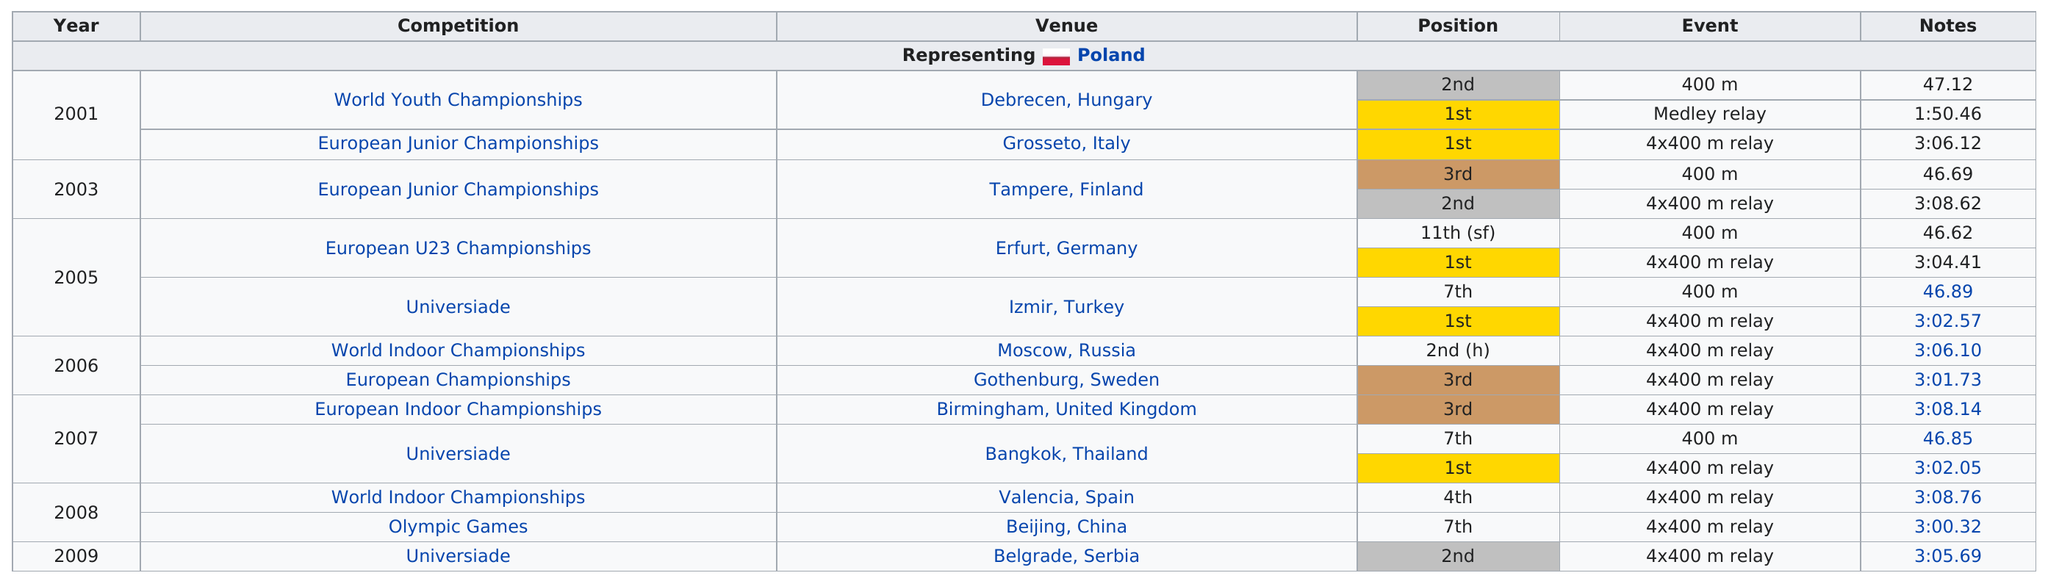List a handful of essential elements in this visual. The competitor competed in the competition that followed the World Indoor Championships in 2008, which was the Olympic Games. Piotr finished in third place a total of [number of times] in [competition or event]. According to the result of the 4x400 meter relay event at the Universiade in 2005, a competitor finished the race in a time of 3:02.57. The Olympic Games is a competition in which they placed no higher than 5th. The number of times they placed first is 5. 